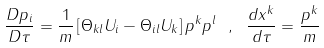Convert formula to latex. <formula><loc_0><loc_0><loc_500><loc_500>\frac { D p _ { i } } { D \tau } = \frac { 1 } { m } \left [ \Theta _ { k l } U _ { i } - \Theta _ { i l } U _ { k } \right ] p ^ { k } p ^ { l } \ , \ \frac { d x ^ { k } } { d \tau } = \frac { p ^ { k } } { m } \</formula> 